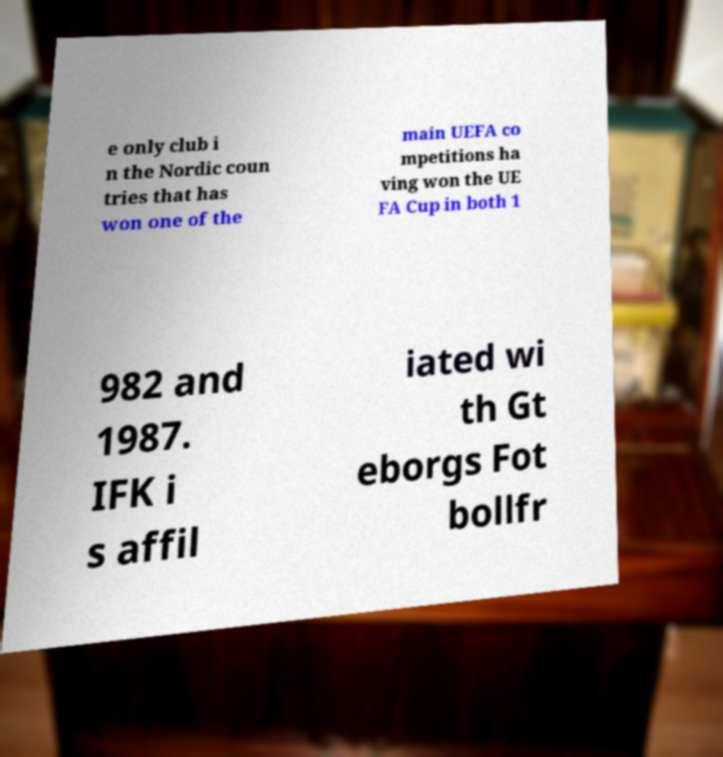Could you assist in decoding the text presented in this image and type it out clearly? e only club i n the Nordic coun tries that has won one of the main UEFA co mpetitions ha ving won the UE FA Cup in both 1 982 and 1987. IFK i s affil iated wi th Gt eborgs Fot bollfr 